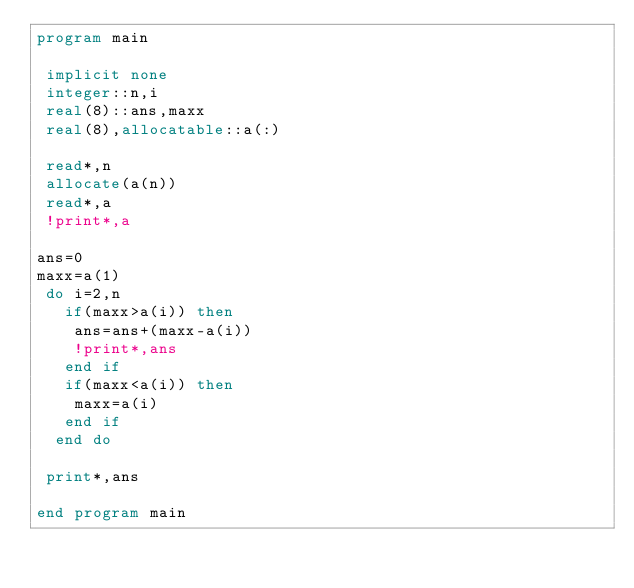<code> <loc_0><loc_0><loc_500><loc_500><_FORTRAN_>program main

 implicit none
 integer::n,i
 real(8)::ans,maxx
 real(8),allocatable::a(:)
 
 read*,n
 allocate(a(n))
 read*,a
 !print*,a

ans=0
maxx=a(1)
 do i=2,n
   if(maxx>a(i)) then
    ans=ans+(maxx-a(i))
    !print*,ans
   end if
   if(maxx<a(i)) then
    maxx=a(i)
   end if
  end do

 print*,ans

end program main</code> 